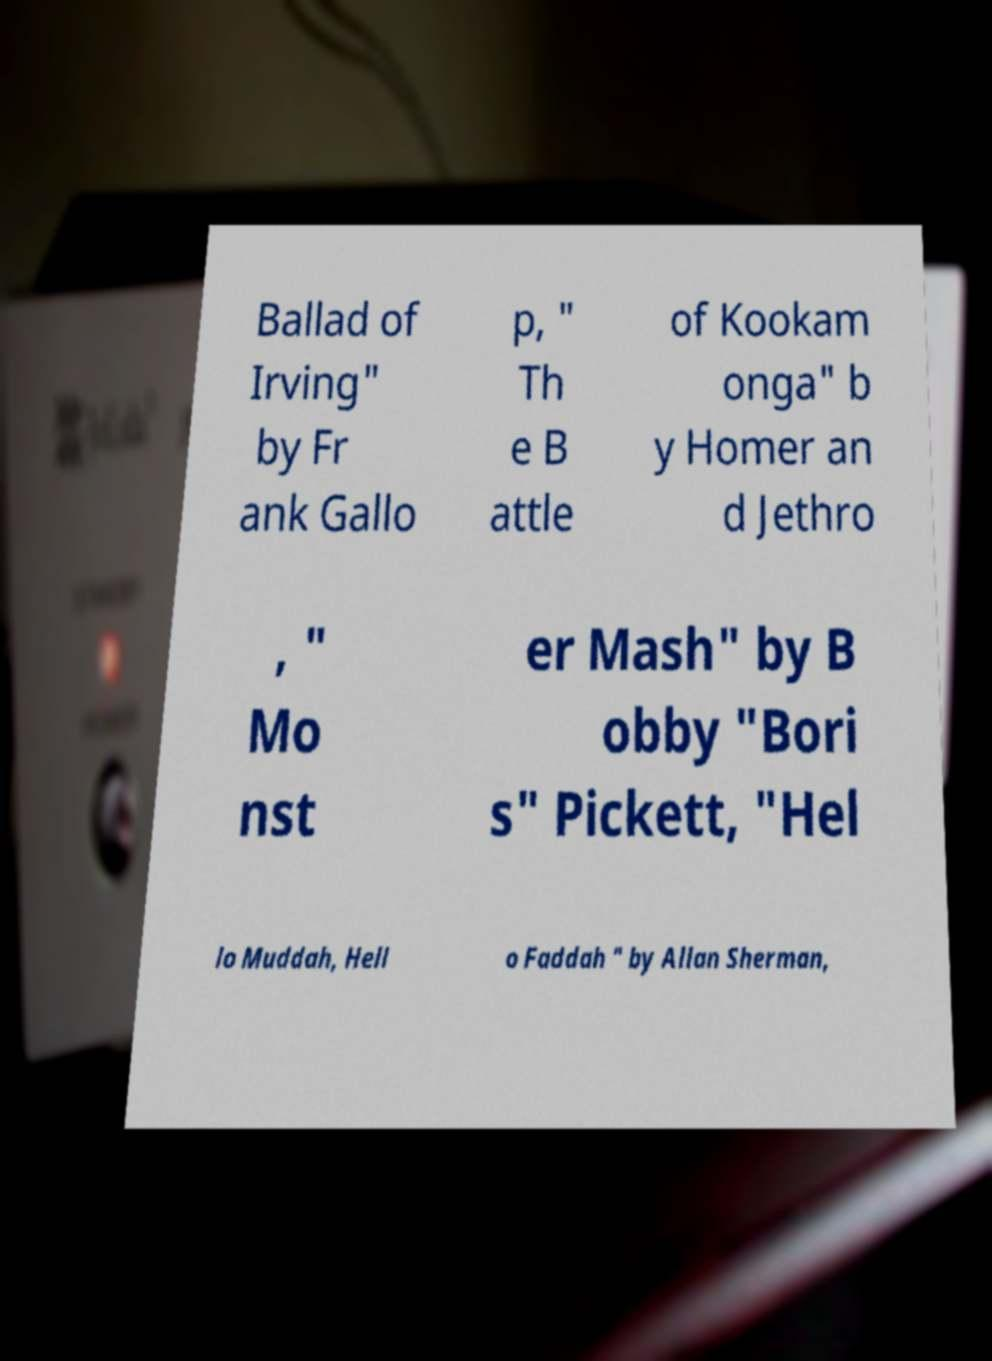Could you extract and type out the text from this image? Ballad of Irving" by Fr ank Gallo p, " Th e B attle of Kookam onga" b y Homer an d Jethro , " Mo nst er Mash" by B obby "Bori s" Pickett, "Hel lo Muddah, Hell o Faddah " by Allan Sherman, 